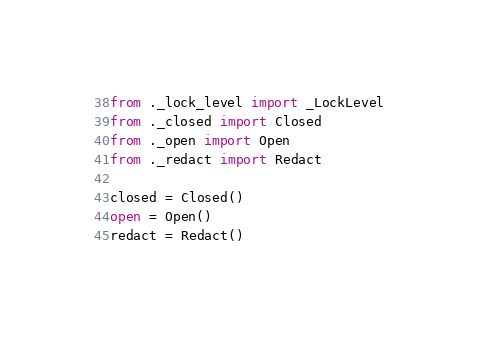Convert code to text. <code><loc_0><loc_0><loc_500><loc_500><_Python_>from ._lock_level import _LockLevel
from ._closed import Closed
from ._open import Open
from ._redact import Redact

closed = Closed()
open = Open()
redact = Redact()
</code> 